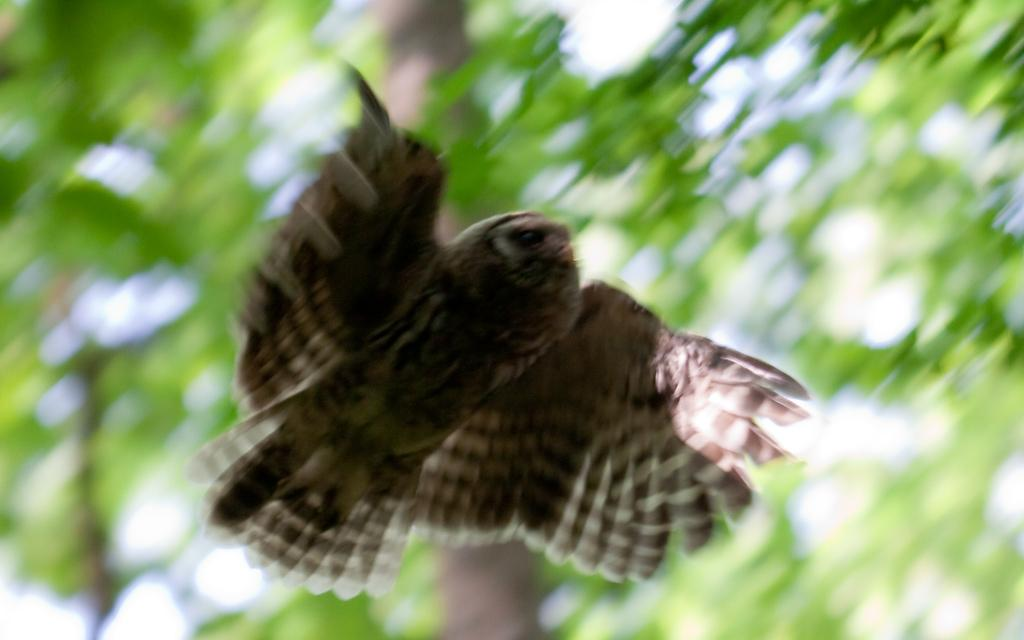What is the main subject of the image? The main subject of the image is a bird flying. What can be seen in the background of the image? There are green plants visible in the background of the image. Where is the sea located in the image? There is no sea present in the image; it features a bird flying and green plants in the background. What type of drink is being served in the hall in the image? There is no hall or drink present in the image. 